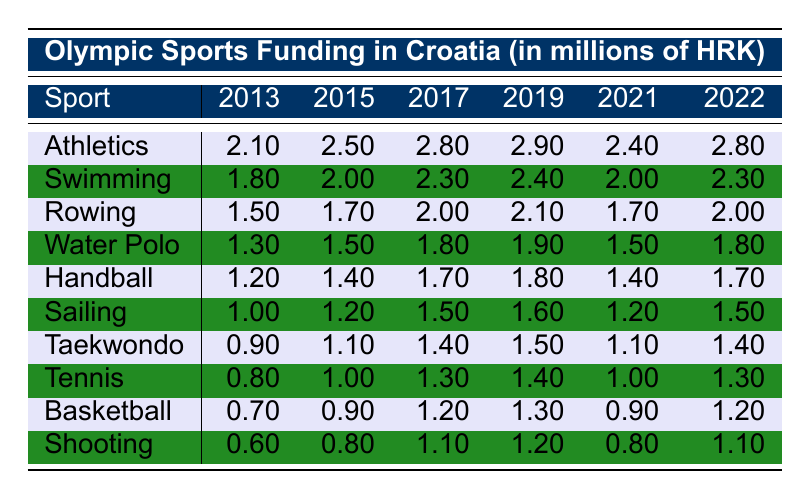What was the funding for Athletics in 2016? The table shows that the funding for Athletics in 2016 is listed as 3.00 million HRK.
Answer: 3.00 million HRK Which sport received the highest funding in 2019? In 2019, Athletics received 2.90 million HRK, which is the highest amount among all sports listed in that year.
Answer: Athletics What was the increase in funding for Swimming from 2013 to 2022? The funding for Swimming increased from 1.80 million HRK in 2013 to 2.30 million HRK in 2022. The increase can be calculated as 2.30 - 1.80 = 0.50 million HRK.
Answer: 0.50 million HRK Is the funding for Handball in 2018 higher or lower than 1.50 million HRK? In 2018, the funding for Handball was 1.40 million HRK, which is lower than 1.50 million HRK.
Answer: Lower What is the average funding for Rowing from 2013 to 2022? The funding for Rowing over the years is 1.50, 1.60, 1.70, 2.20, 2.00, 1.90, 2.10, 1.80, 1.70, and 2.00 million HRK. Summing these gives 19.50 million HRK, and dividing by 10 (the number of years) gives an average of 1.95 million HRK.
Answer: 1.95 million HRK Which two sports had the highest funding in 2021, and what were their amounts? In 2021, Athletics received 2.40 million HRK, and Swimming received 2.00 million HRK. Therefore, Athletics and Swimming had the highest funding in that year.
Answer: Athletics (2.40 million HRK), Swimming (2.00 million HRK) What trend can be seen in the funding for Sailing over the years? Sailing received decreasing funding for the first few years, with a notable rise afterwards. Specifically, it started at 1.00 million in 2013, peaked in 2017 at 1.60 million, and was back to 1.50 million in 2022.
Answer: Fluctuating with a peak in 2017 What is the difference in funding for Basketball between 2015 and 2022? The funding for Basketball in 2015 was 0.90 million HRK, and in 2022 it was 1.20 million HRK. Therefore, the difference is 1.20 - 0.90 = 0.30 million HRK.
Answer: 0.30 million HRK Which sports have consistently received less than 1 million HRK over the decade? In the data, both Tennis and Shooting received amounts below 1 million in the initial years but had their funding rise later. However, throughout the decade, Tennis did not exceed 1.30 million HRK while Shooting rose to 1.10 million in 2022. Thus, neither consistently stayed below 1 million HRK.
Answer: None How does the funding for Taekwondo compare from 2013 to 2022? In 2013, Taekwondo received 0.90 million HRK, which increased to 1.40 million HRK in 2022, demonstrating a positive trend in funding.
Answer: Increased by 0.50 million HRK 